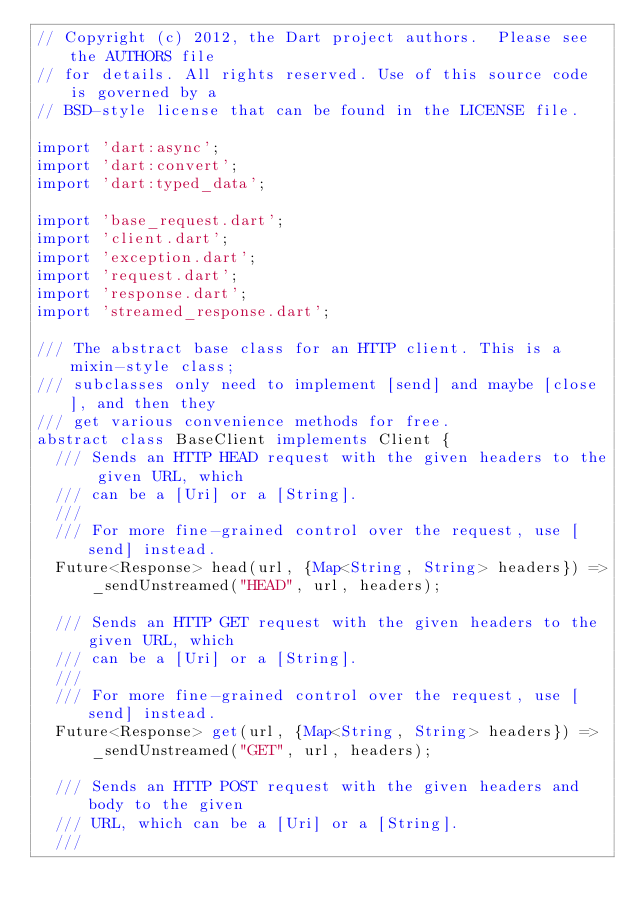Convert code to text. <code><loc_0><loc_0><loc_500><loc_500><_Dart_>// Copyright (c) 2012, the Dart project authors.  Please see the AUTHORS file
// for details. All rights reserved. Use of this source code is governed by a
// BSD-style license that can be found in the LICENSE file.

import 'dart:async';
import 'dart:convert';
import 'dart:typed_data';

import 'base_request.dart';
import 'client.dart';
import 'exception.dart';
import 'request.dart';
import 'response.dart';
import 'streamed_response.dart';

/// The abstract base class for an HTTP client. This is a mixin-style class;
/// subclasses only need to implement [send] and maybe [close], and then they
/// get various convenience methods for free.
abstract class BaseClient implements Client {
  /// Sends an HTTP HEAD request with the given headers to the given URL, which
  /// can be a [Uri] or a [String].
  ///
  /// For more fine-grained control over the request, use [send] instead.
  Future<Response> head(url, {Map<String, String> headers}) =>
      _sendUnstreamed("HEAD", url, headers);

  /// Sends an HTTP GET request with the given headers to the given URL, which
  /// can be a [Uri] or a [String].
  ///
  /// For more fine-grained control over the request, use [send] instead.
  Future<Response> get(url, {Map<String, String> headers}) =>
      _sendUnstreamed("GET", url, headers);

  /// Sends an HTTP POST request with the given headers and body to the given
  /// URL, which can be a [Uri] or a [String].
  ///</code> 